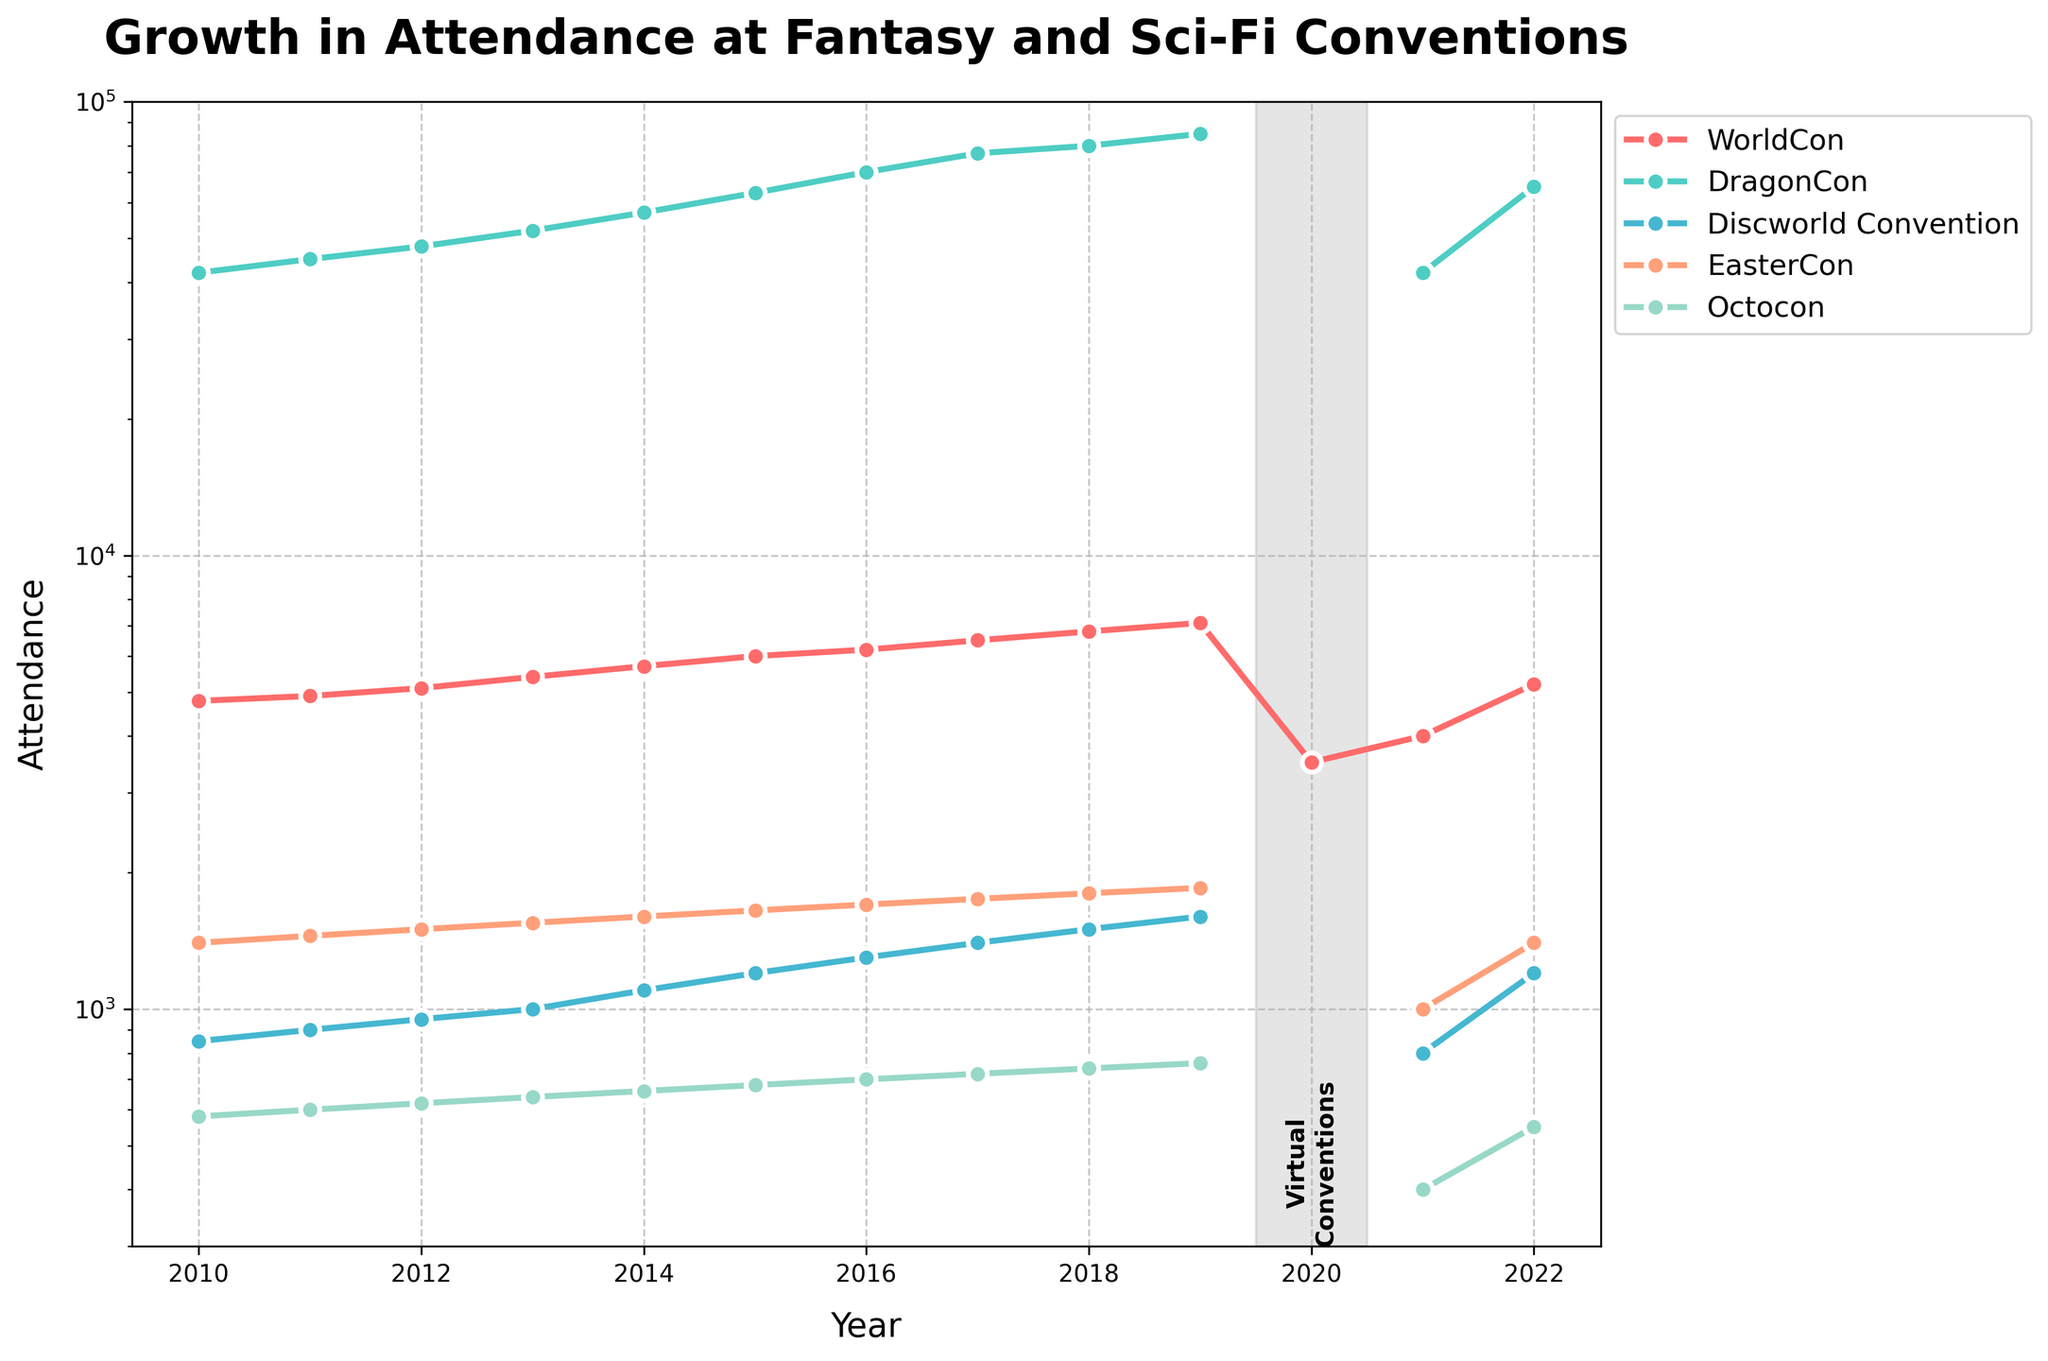What's the trend of attendance for the Discworld Convention between 2010 and 2019? Starting from 850 in 2010, the attendance gradually increases each year, reaching 1600 in 2019.
Answer: It increased consistently Which convention had the highest attendance in 2019? In 2019, comparing the data points for all conventions, DragonCon had the highest attendance at 85,000.
Answer: DragonCon What happened to the attendance for all conventions in 2020? All conventions are marked as "Virtual" for 2020, indicating they likely were not held in-person due to external factors like the COVID-19 pandemic.
Answer: They went virtual How does the attendance of DragonCon in 2021 compare to that in 2019? DragonCon's attendance dropped significantly from 85,000 in 2019 to 42,000 in 2021.
Answer: It decreased What color represents the WorldCon data line, and how does this help in interpreting the data? The WorldCon data line is represented in red, making it visually distinct and easy to follow its trend from 2010 to 2022.
Answer: Red Analyze the attendance change for EasterCon between 2011 and 2018 In 2011, attendance was 1450. By 2018, it increased consistently each year, reaching 1800. The total change is 1800 - 1450 = 350.
Answer: 350 increase How did the attendance for Octocon change from 2011 to 2022 and what might this signify? Attendance rose from 600 in 2011 to a peak of 760 in 2019, dipped to 400 in 2021, and recovered to 550 in 2022, indicating potential influence by external events such as the pandemic.
Answer: Fluctuated with peaks and dips What significant annotation is made regarding the Discworld Convention data point for 2019, and why is it significant? The Discworld Convention data point for 2019 is annotated to draw attention to its notable ending value of 1600 before the virtual shift in 2020.
Answer: Highlighted Discworld Convention at 1600 Compare the lowest attendance for WorldCon and EasterCon over the plotted years. The lowest attendance for WorldCon was 3500 in 2020, while for EasterCon it was 1000, also in 2020.
Answer: WorldCon: 3500, EasterCon: 1000 What happens to the attendance trend when the y-axis is log-scale and why might this be useful? The log-scale on the y-axis compresses large ranges of data, making it easier to observe growth and patterns over time. It avoids skewing due to very high attendance values like those in DragonCon.
Answer: Eases pattern observation 